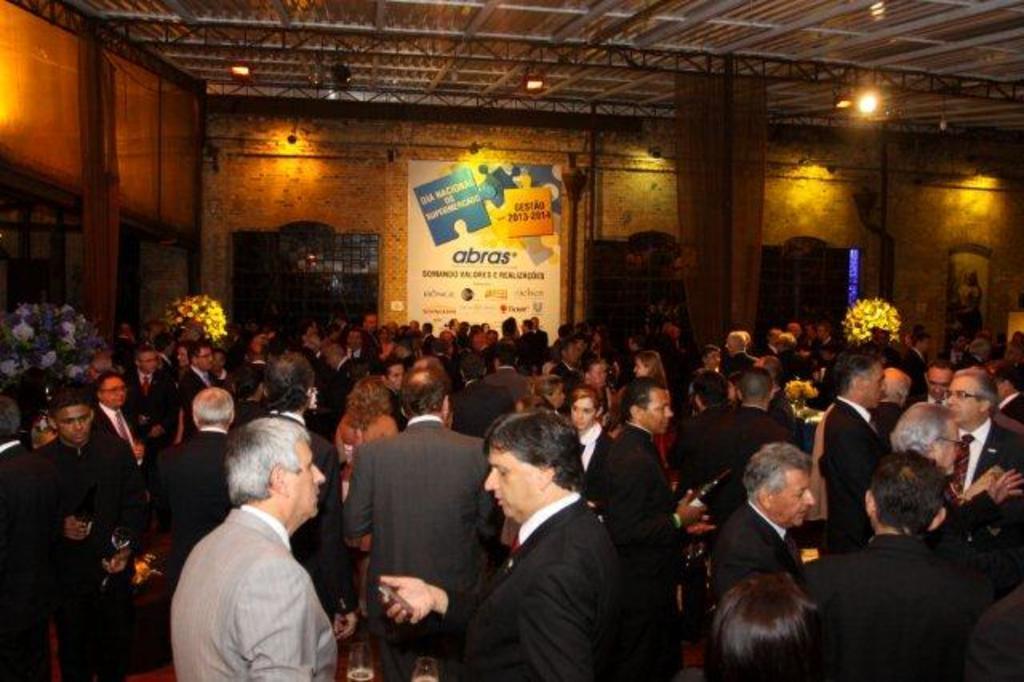Describe this image in one or two sentences. In this image there are so many people standing in a closed room. In the background there is a banner hanging on the wall and windows. At the top of the image there is a ceiling. 